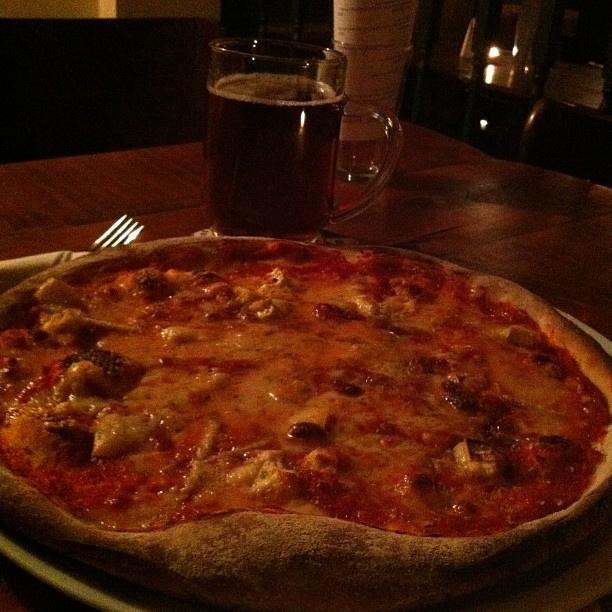Verify the accuracy of this image caption: "The pizza is off the dining table.".
Answer yes or no. No. 